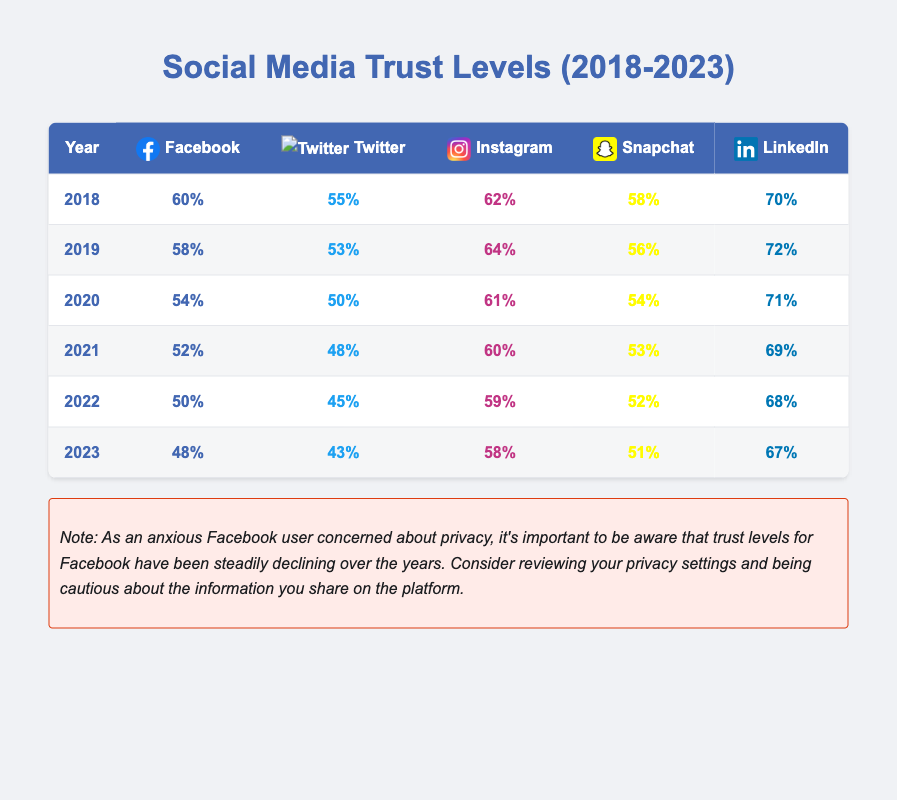What was the trust level for Facebook in 2020? The trust level for Facebook in 2020 is given in the table as 54%.
Answer: 54% In which year did Instagram have the highest trust level? By examining the table, Instagram's highest trust level was in 2019 at 64%.
Answer: 2019 What is the difference in trust levels for Twitter from 2018 to 2023? The trust level for Twitter in 2018 is 55% and in 2023 is 43%. The difference is 55% - 43% = 12%.
Answer: 12% Which platform had the most consistent trust levels from 2018 to 2023? By analyzing the data, LinkedIn's trust levels changed less over the years; it started at 70% in 2018 and ended at 67% in 2023. This is a decrease of only 3%.
Answer: LinkedIn What was the average trust level for Snapchat from 2018 to 2023? To find the average for Snapchat, we sum its trust levels (58 + 56 + 54 + 53 + 52 + 51) = 324, and divide by 6 years: 324 / 6 = 54%.
Answer: 54% Is there a trend of decreasing trust levels for Facebook year over year? Observing the table shows that Facebook's trust level consistently declines from 60% in 2018 to 48% in 2023. Thus, the trend is decreasing.
Answer: Yes What was the trust level for Instagram in 2022, and how does it compare to its 2021 trust level? The trust level for Instagram in 2022 is 59%. Comparing it to 2021, which is 60%, shows a decrease of 1%.
Answer: 59%, decreased by 1% from 2021 What is the lowest trust level reported for any platform between 2018 and 2023? By reviewing the table, the lowest reported trust level is for Twitter in 2023 at 43%.
Answer: 43% 